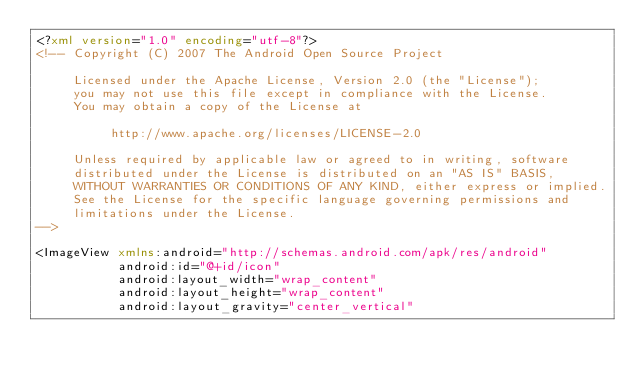Convert code to text. <code><loc_0><loc_0><loc_500><loc_500><_XML_><?xml version="1.0" encoding="utf-8"?>
<!-- Copyright (C) 2007 The Android Open Source Project

     Licensed under the Apache License, Version 2.0 (the "License");
     you may not use this file except in compliance with the License.
     You may obtain a copy of the License at
  
          http://www.apache.org/licenses/LICENSE-2.0
  
     Unless required by applicable law or agreed to in writing, software
     distributed under the License is distributed on an "AS IS" BASIS,
     WITHOUT WARRANTIES OR CONDITIONS OF ANY KIND, either express or implied.
     See the License for the specific language governing permissions and
     limitations under the License.
-->

<ImageView xmlns:android="http://schemas.android.com/apk/res/android"
           android:id="@+id/icon"
           android:layout_width="wrap_content"
           android:layout_height="wrap_content"
           android:layout_gravity="center_vertical"</code> 